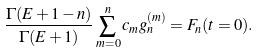<formula> <loc_0><loc_0><loc_500><loc_500>\frac { \Gamma ( E + 1 - n ) } { \Gamma ( E + 1 ) } \sum _ { m = 0 } ^ { n } c _ { m } g _ { n } ^ { ( m ) } = F _ { n } ( t = 0 ) .</formula> 